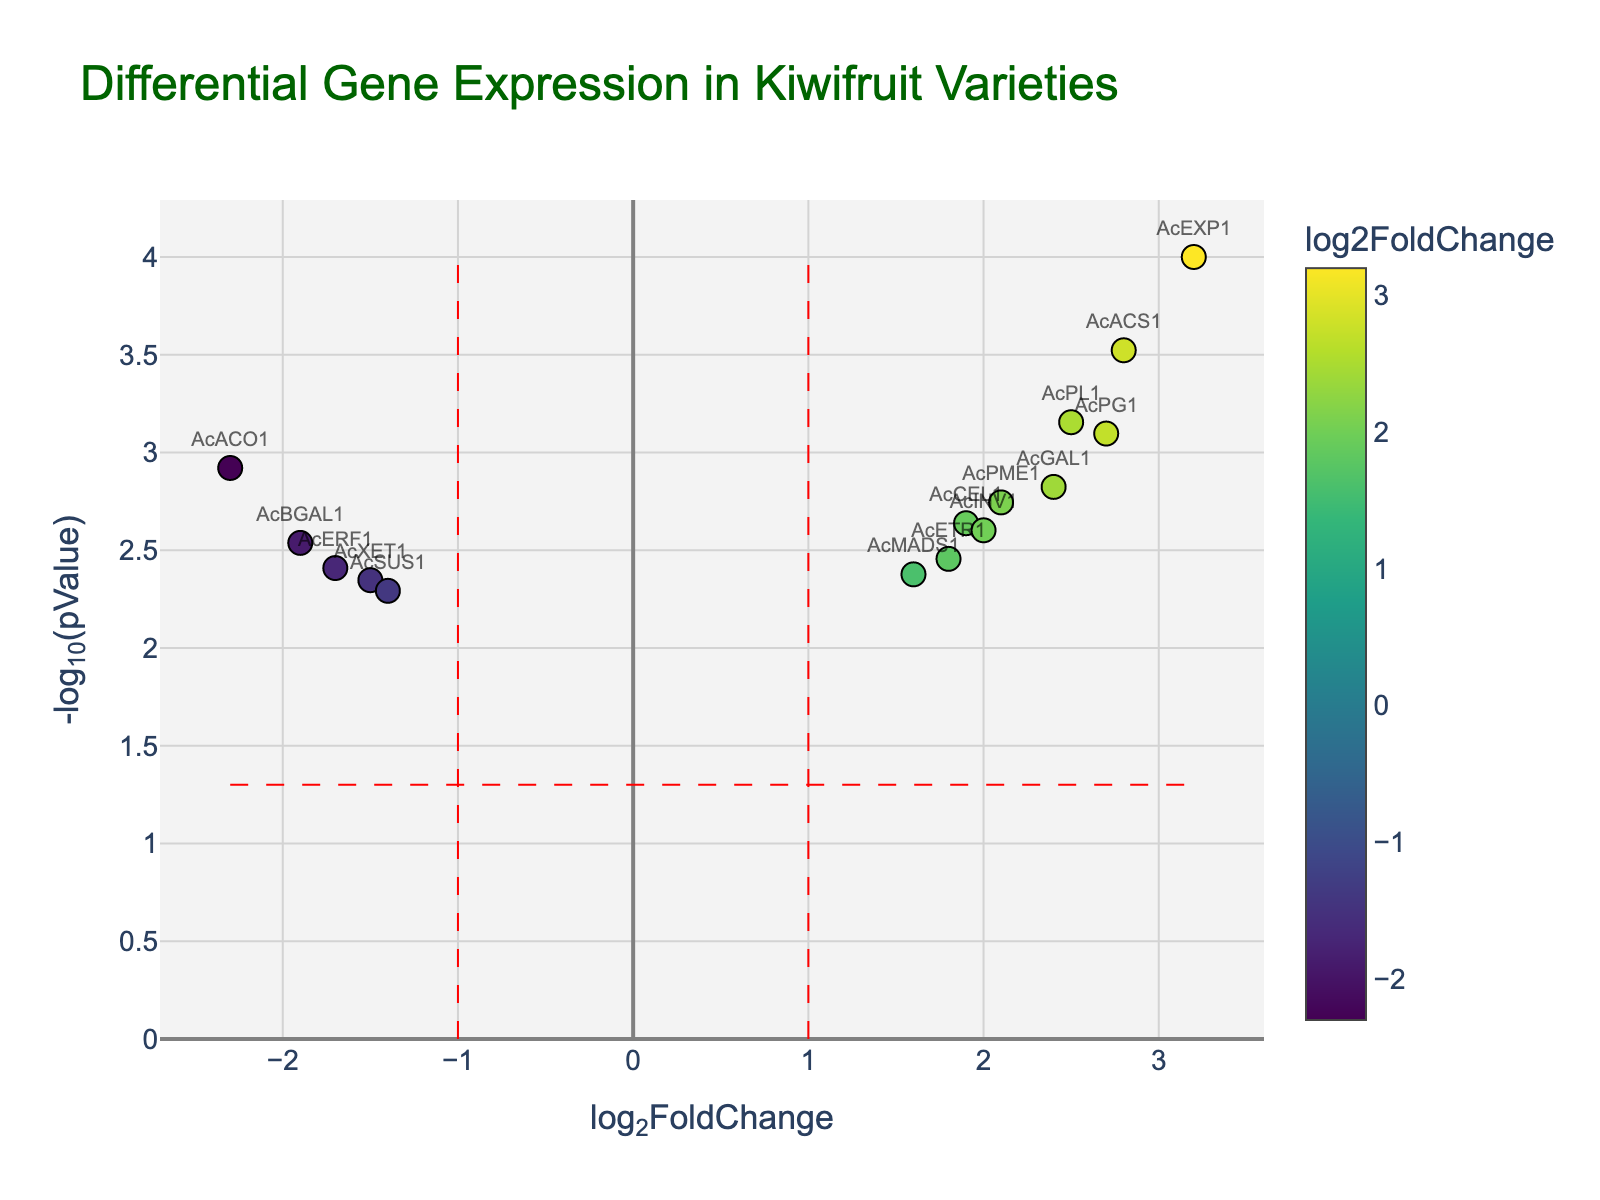What is the title of the plot? The title of the plot can be seen at the top of the figure. It provides a summary of what the plot represents.
Answer: 'Differential Gene Expression in Kiwifruit Varieties' What does the x-axis represent? The x-axis title is provided at the bottom of the x-axis. It represents the log2 fold change in gene expression.
Answer: 'log2FoldChange' What does the y-axis represent? The y-axis title is provided at the side of the y-axis. It represents the negative log10 of the p-values.
Answer: '-log10(pValue)' How many genes have a log2FoldChange greater than 2? To find this, locate the data points on the plot where the x-value (log2FoldChange) is greater than 2 and count these points. Genes corresponding to these points are AcEXP1, AcPG1, AcACS1, and AcPL1.
Answer: 4 genes Which gene has the highest log2FoldChange? Identify the data point with the highest x-value on the plot. The hover text or labels can help identify the gene name. In this case, AcEXP1 has the highest log2FoldChange of 3.2.
Answer: AcEXP1 Which gene has the lowest p-value? The lowest p-value corresponds to the highest y-value on the plot because the y-axis is -log10(pValue). The gene AcEXP1 has the highest y-value indicating the lowest p-value.
Answer: AcEXP1 Which genes have a log2FoldChange less than -1? Locate the data points on the plot where the x-value (log2FoldChange) is less than -1 and list these points. The genes corresponding to these points are AcACO1, AcXET1, AcERF1, and AcBGAL1.
Answer: AcACO1, AcXET1, AcERF1, AcBGAL1 What is the threshold of significance for the p-values, and is it shown on the plot? The threshold of significance for p-values is often set at 0.05, which translates to a -log10(pValue) of 1.3. This threshold is shown as a horizontal red dashed line on the plot.
Answer: -log10(pValue) = 1.3 (pValue = 0.05) Which genes fall outside the vertical lines at log2FoldChange = -1 and 1? Determine the genes that have log2FoldChange values greater than 1 or less than -1. The genes that meet this criterion are AcACO1, AcETR1, AcEXP1, AcPG1, AcXET1, AcCEL1, AcPME1, AcACS1, AcERF1, AcGAL1, AcBGAL1, AcPL1, and AcINV1.
Answer: All except AcSUS1, AcMADS1 